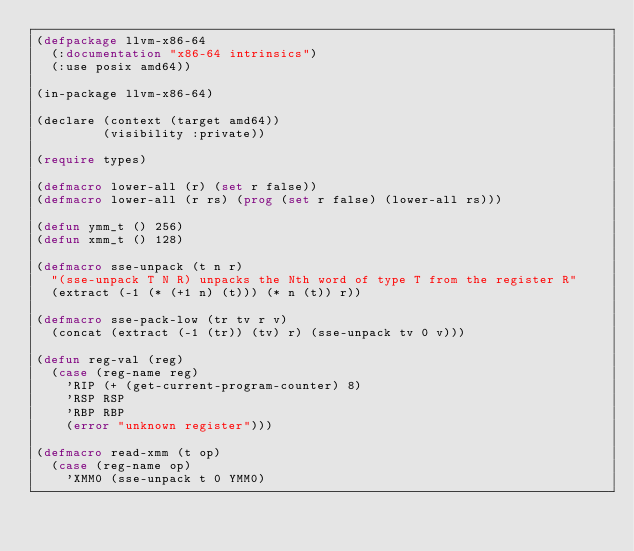<code> <loc_0><loc_0><loc_500><loc_500><_Lisp_>(defpackage llvm-x86-64
  (:documentation "x86-64 intrinsics")
  (:use posix amd64))

(in-package llvm-x86-64)

(declare (context (target amd64))
         (visibility :private))

(require types)

(defmacro lower-all (r) (set r false))
(defmacro lower-all (r rs) (prog (set r false) (lower-all rs)))

(defun ymm_t () 256)
(defun xmm_t () 128)

(defmacro sse-unpack (t n r)
  "(sse-unpack T N R) unpacks the Nth word of type T from the register R"
  (extract (-1 (* (+1 n) (t))) (* n (t)) r))

(defmacro sse-pack-low (tr tv r v)
  (concat (extract (-1 (tr)) (tv) r) (sse-unpack tv 0 v)))

(defun reg-val (reg)
  (case (reg-name reg)
    'RIP (+ (get-current-program-counter) 8)
    'RSP RSP
    'RBP RBP
    (error "unknown register")))

(defmacro read-xmm (t op)
  (case (reg-name op)
    'XMM0 (sse-unpack t 0 YMM0)</code> 